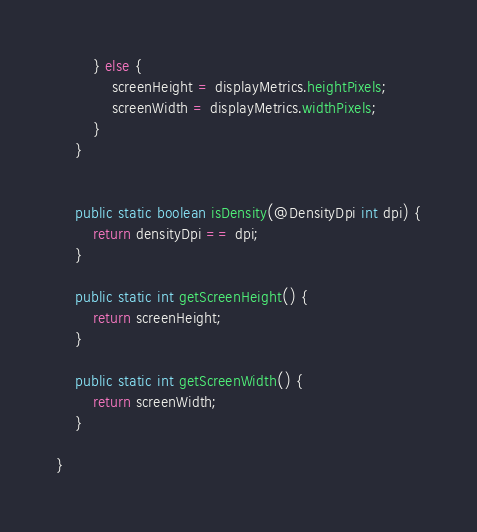Convert code to text. <code><loc_0><loc_0><loc_500><loc_500><_Java_>		} else {
			screenHeight = displayMetrics.heightPixels;
			screenWidth = displayMetrics.widthPixels;
		}
	}


	public static boolean isDensity(@DensityDpi int dpi) {
		return densityDpi == dpi;
	}

	public static int getScreenHeight() {
		return screenHeight;
	}

	public static int getScreenWidth() {
		return screenWidth;
	}

}
</code> 